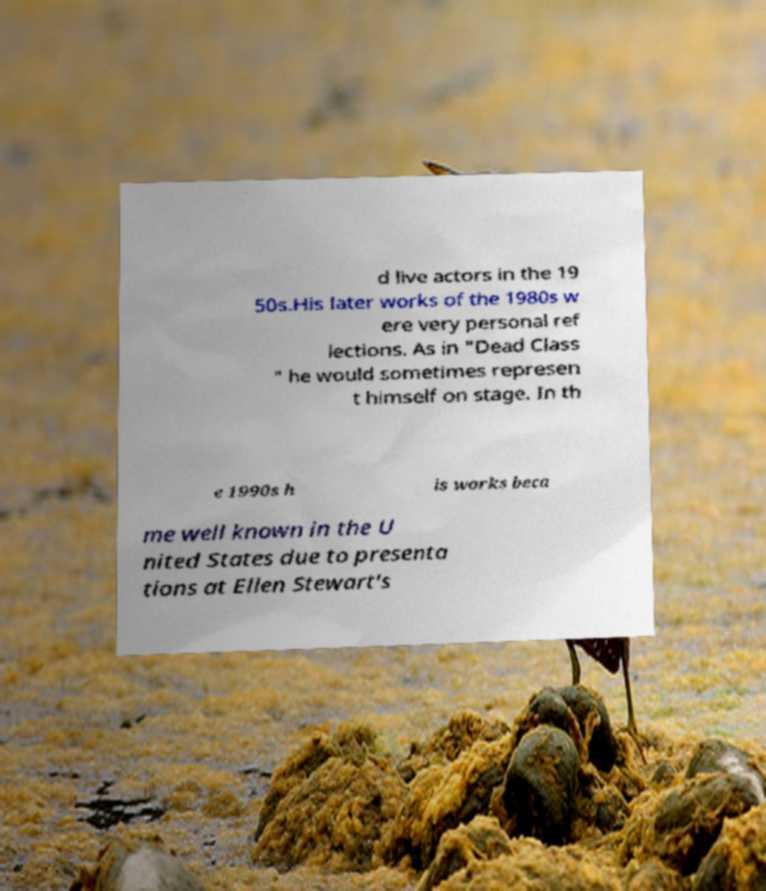For documentation purposes, I need the text within this image transcribed. Could you provide that? d live actors in the 19 50s.His later works of the 1980s w ere very personal ref lections. As in "Dead Class " he would sometimes represen t himself on stage. In th e 1990s h is works beca me well known in the U nited States due to presenta tions at Ellen Stewart's 